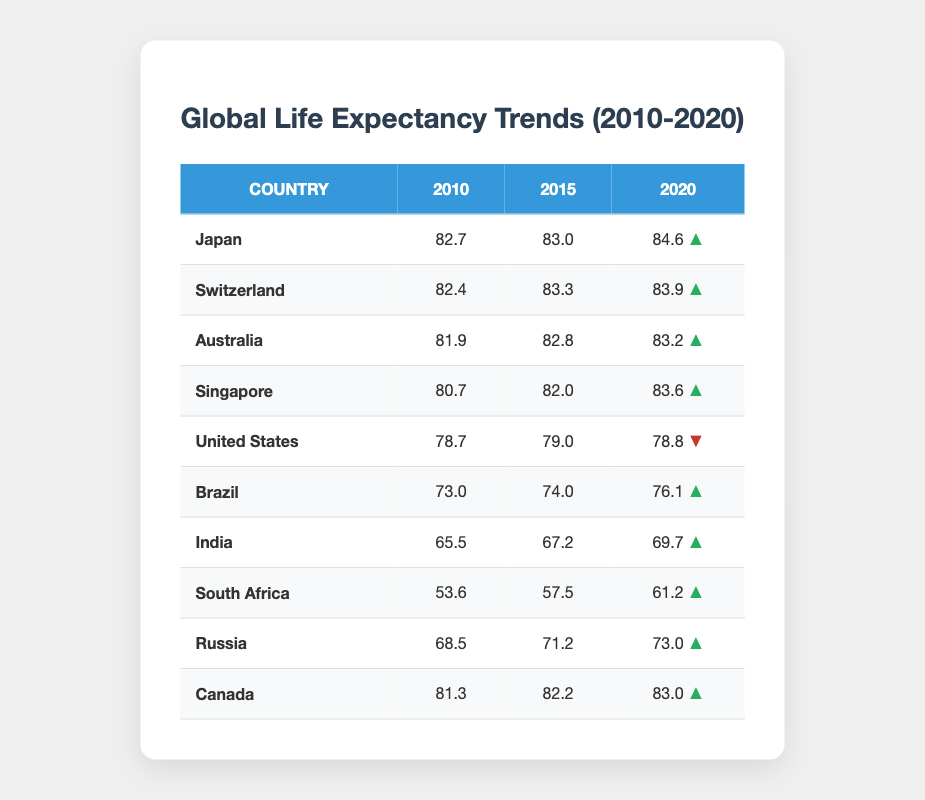What country had the highest life expectancy in 2020? Looking at the last column for 2020, Japan has the highest life expectancy listed at 84.6 years, which is greater than that of any other country in the table.
Answer: Japan Did the life expectancy in the United States increase from 2010 to 2015? In 2010, the life expectancy for the United States was 78.7 years, and in 2015 it increased slightly to 79.0 years. Therefore, it did increase during that time.
Answer: Yes What is the average life expectancy of Brazil from 2010 to 2020? The life expectancies for Brazil over the three years are 73.0, 74.0, and 76.1. To find the average, we sum them up: 73.0 + 74.0 + 76.1 = 223.1. Then, divide by 3 to get the average: 223.1 / 3 = 74.3667, which rounded is approximately 74.4.
Answer: 74.4 Which country showed the least improvement in life expectancy from 2010 to 2020? By comparing the changes from 2010 to 2020, the United States has a life expectancy of 78.7 in 2010 and 78.8 in 2020, resulting in a net change of only 0.1 years. This is less improvement compared to all other countries.
Answer: United States Is the life expectancy in South Africa above 60 years in 2020? The life expectancy for South Africa in 2020 is 61.2 years, which is above 60 years.
Answer: Yes What is the difference in life expectancy between Canada in 2010 and Australia in 2020? Canada had a life expectancy of 81.3 in 2010, and Australia had a life expectancy of 83.2 in 2020. To find the difference, we calculate: 83.2 - 81.3 = 1.9 years.
Answer: 1.9 Which countries had a life expectancy increase greater than 3 years between 2010 and 2020? We can calculate the increase for each country: Japan (84.6 - 82.7 = 1.9), Switzerland (83.9 - 82.4 = 1.5), Australia (83.2 - 81.9 = 1.3), Singapore (83.6 - 80.7 = 2.9), Brazil (76.1 - 73.0 = 3.1), India (69.7 - 65.5 = 4.2), South Africa (61.2 - 53.6 = 7.6), Russia (73.0 - 68.5 = 4.5), and Canada (83.0 - 81.3 = 1.7). The only countries with increases greater than 3 years are Brazil, India, South Africa, and Russia.
Answer: Brazil, India, South Africa, Russia Which country had the lowest life expectancy in 2010? Checking the first column for 2010, India has the lowest life expectancy at 65.5 years compared to all other countries in the table.
Answer: India 